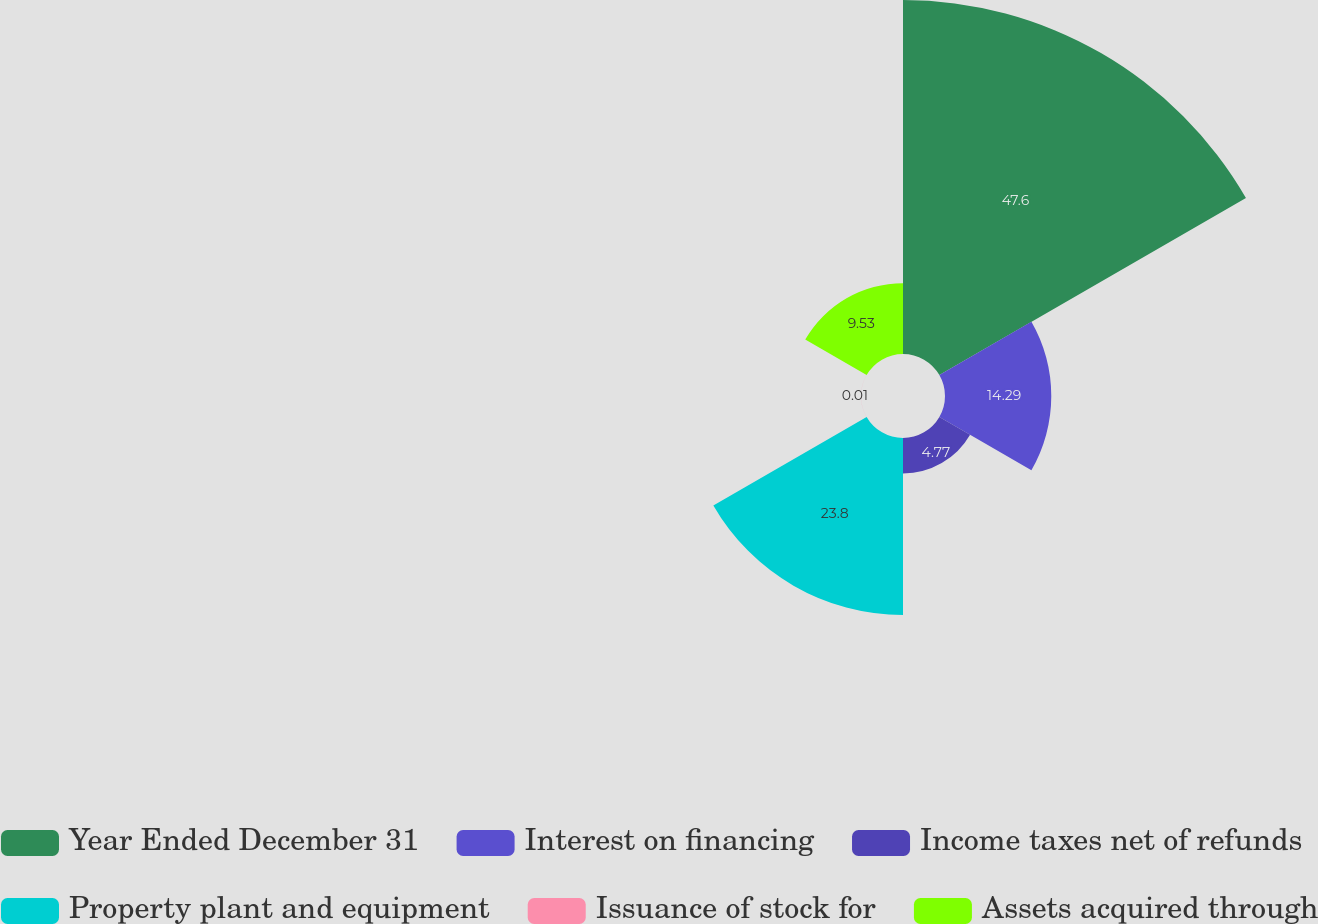<chart> <loc_0><loc_0><loc_500><loc_500><pie_chart><fcel>Year Ended December 31<fcel>Interest on financing<fcel>Income taxes net of refunds<fcel>Property plant and equipment<fcel>Issuance of stock for<fcel>Assets acquired through<nl><fcel>47.6%<fcel>14.29%<fcel>4.77%<fcel>23.8%<fcel>0.01%<fcel>9.53%<nl></chart> 